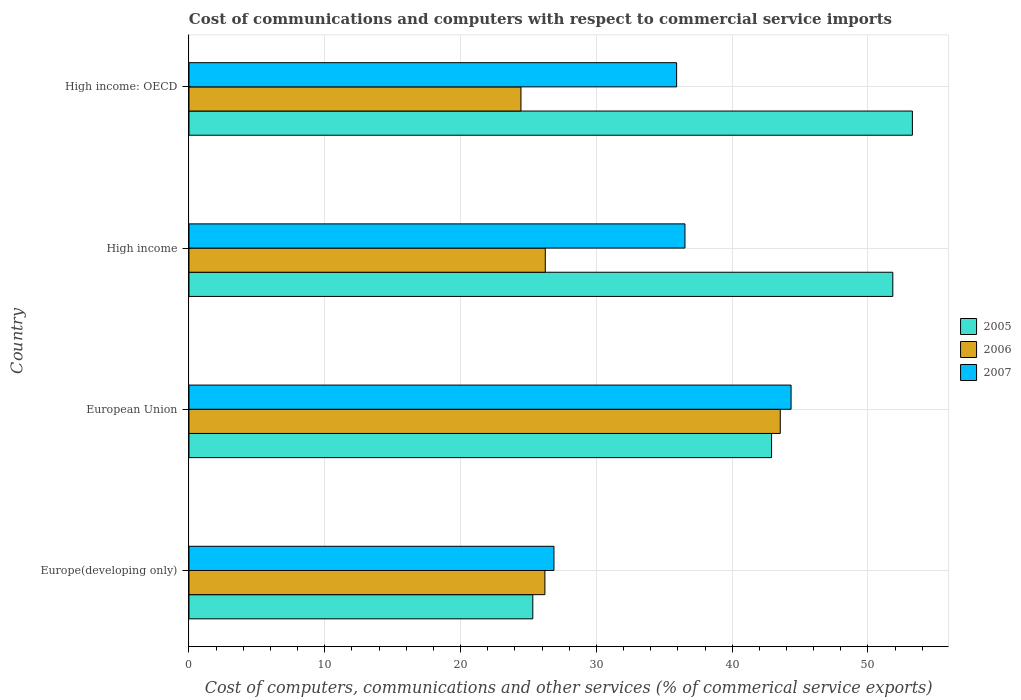How many different coloured bars are there?
Offer a terse response. 3. Are the number of bars per tick equal to the number of legend labels?
Provide a succinct answer. Yes. How many bars are there on the 1st tick from the top?
Give a very brief answer. 3. In how many cases, is the number of bars for a given country not equal to the number of legend labels?
Provide a short and direct response. 0. What is the cost of communications and computers in 2006 in High income?
Keep it short and to the point. 26.24. Across all countries, what is the maximum cost of communications and computers in 2005?
Keep it short and to the point. 53.27. Across all countries, what is the minimum cost of communications and computers in 2005?
Keep it short and to the point. 25.32. In which country was the cost of communications and computers in 2006 maximum?
Keep it short and to the point. European Union. In which country was the cost of communications and computers in 2007 minimum?
Ensure brevity in your answer.  Europe(developing only). What is the total cost of communications and computers in 2006 in the graph?
Provide a short and direct response. 120.44. What is the difference between the cost of communications and computers in 2007 in High income and that in High income: OECD?
Keep it short and to the point. 0.61. What is the difference between the cost of communications and computers in 2005 in High income: OECD and the cost of communications and computers in 2006 in High income?
Your response must be concise. 27.03. What is the average cost of communications and computers in 2006 per country?
Ensure brevity in your answer.  30.11. What is the difference between the cost of communications and computers in 2005 and cost of communications and computers in 2006 in High income?
Your response must be concise. 25.59. What is the ratio of the cost of communications and computers in 2007 in Europe(developing only) to that in High income?
Provide a short and direct response. 0.74. Is the cost of communications and computers in 2005 in Europe(developing only) less than that in High income: OECD?
Your answer should be very brief. Yes. Is the difference between the cost of communications and computers in 2005 in Europe(developing only) and High income: OECD greater than the difference between the cost of communications and computers in 2006 in Europe(developing only) and High income: OECD?
Offer a terse response. No. What is the difference between the highest and the second highest cost of communications and computers in 2007?
Your answer should be compact. 7.81. What is the difference between the highest and the lowest cost of communications and computers in 2006?
Offer a terse response. 19.1. In how many countries, is the cost of communications and computers in 2007 greater than the average cost of communications and computers in 2007 taken over all countries?
Provide a short and direct response. 2. Is it the case that in every country, the sum of the cost of communications and computers in 2005 and cost of communications and computers in 2007 is greater than the cost of communications and computers in 2006?
Your answer should be compact. Yes. How many bars are there?
Provide a succinct answer. 12. Are all the bars in the graph horizontal?
Keep it short and to the point. Yes. How many countries are there in the graph?
Provide a short and direct response. 4. Are the values on the major ticks of X-axis written in scientific E-notation?
Ensure brevity in your answer.  No. Does the graph contain any zero values?
Offer a terse response. No. Does the graph contain grids?
Your response must be concise. Yes. Where does the legend appear in the graph?
Your response must be concise. Center right. What is the title of the graph?
Provide a short and direct response. Cost of communications and computers with respect to commercial service imports. What is the label or title of the X-axis?
Ensure brevity in your answer.  Cost of computers, communications and other services (% of commerical service exports). What is the label or title of the Y-axis?
Offer a terse response. Country. What is the Cost of computers, communications and other services (% of commerical service exports) of 2005 in Europe(developing only)?
Ensure brevity in your answer.  25.32. What is the Cost of computers, communications and other services (% of commerical service exports) of 2006 in Europe(developing only)?
Give a very brief answer. 26.21. What is the Cost of computers, communications and other services (% of commerical service exports) in 2007 in Europe(developing only)?
Your response must be concise. 26.88. What is the Cost of computers, communications and other services (% of commerical service exports) of 2005 in European Union?
Ensure brevity in your answer.  42.9. What is the Cost of computers, communications and other services (% of commerical service exports) in 2006 in European Union?
Provide a short and direct response. 43.54. What is the Cost of computers, communications and other services (% of commerical service exports) of 2007 in European Union?
Give a very brief answer. 44.34. What is the Cost of computers, communications and other services (% of commerical service exports) in 2005 in High income?
Make the answer very short. 51.83. What is the Cost of computers, communications and other services (% of commerical service exports) of 2006 in High income?
Keep it short and to the point. 26.24. What is the Cost of computers, communications and other services (% of commerical service exports) in 2007 in High income?
Offer a very short reply. 36.52. What is the Cost of computers, communications and other services (% of commerical service exports) of 2005 in High income: OECD?
Your answer should be compact. 53.27. What is the Cost of computers, communications and other services (% of commerical service exports) of 2006 in High income: OECD?
Offer a very short reply. 24.45. What is the Cost of computers, communications and other services (% of commerical service exports) in 2007 in High income: OECD?
Offer a very short reply. 35.91. Across all countries, what is the maximum Cost of computers, communications and other services (% of commerical service exports) of 2005?
Keep it short and to the point. 53.27. Across all countries, what is the maximum Cost of computers, communications and other services (% of commerical service exports) in 2006?
Make the answer very short. 43.54. Across all countries, what is the maximum Cost of computers, communications and other services (% of commerical service exports) in 2007?
Ensure brevity in your answer.  44.34. Across all countries, what is the minimum Cost of computers, communications and other services (% of commerical service exports) of 2005?
Your response must be concise. 25.32. Across all countries, what is the minimum Cost of computers, communications and other services (% of commerical service exports) in 2006?
Provide a succinct answer. 24.45. Across all countries, what is the minimum Cost of computers, communications and other services (% of commerical service exports) in 2007?
Your answer should be very brief. 26.88. What is the total Cost of computers, communications and other services (% of commerical service exports) in 2005 in the graph?
Offer a very short reply. 173.32. What is the total Cost of computers, communications and other services (% of commerical service exports) in 2006 in the graph?
Keep it short and to the point. 120.44. What is the total Cost of computers, communications and other services (% of commerical service exports) in 2007 in the graph?
Offer a very short reply. 143.65. What is the difference between the Cost of computers, communications and other services (% of commerical service exports) in 2005 in Europe(developing only) and that in European Union?
Ensure brevity in your answer.  -17.58. What is the difference between the Cost of computers, communications and other services (% of commerical service exports) in 2006 in Europe(developing only) and that in European Union?
Offer a very short reply. -17.33. What is the difference between the Cost of computers, communications and other services (% of commerical service exports) in 2007 in Europe(developing only) and that in European Union?
Your response must be concise. -17.46. What is the difference between the Cost of computers, communications and other services (% of commerical service exports) in 2005 in Europe(developing only) and that in High income?
Offer a very short reply. -26.51. What is the difference between the Cost of computers, communications and other services (% of commerical service exports) in 2006 in Europe(developing only) and that in High income?
Your answer should be very brief. -0.03. What is the difference between the Cost of computers, communications and other services (% of commerical service exports) in 2007 in Europe(developing only) and that in High income?
Offer a terse response. -9.65. What is the difference between the Cost of computers, communications and other services (% of commerical service exports) in 2005 in Europe(developing only) and that in High income: OECD?
Offer a very short reply. -27.95. What is the difference between the Cost of computers, communications and other services (% of commerical service exports) in 2006 in Europe(developing only) and that in High income: OECD?
Give a very brief answer. 1.76. What is the difference between the Cost of computers, communications and other services (% of commerical service exports) of 2007 in Europe(developing only) and that in High income: OECD?
Your answer should be very brief. -9.03. What is the difference between the Cost of computers, communications and other services (% of commerical service exports) of 2005 in European Union and that in High income?
Provide a succinct answer. -8.93. What is the difference between the Cost of computers, communications and other services (% of commerical service exports) in 2006 in European Union and that in High income?
Make the answer very short. 17.3. What is the difference between the Cost of computers, communications and other services (% of commerical service exports) of 2007 in European Union and that in High income?
Keep it short and to the point. 7.81. What is the difference between the Cost of computers, communications and other services (% of commerical service exports) of 2005 in European Union and that in High income: OECD?
Keep it short and to the point. -10.37. What is the difference between the Cost of computers, communications and other services (% of commerical service exports) of 2006 in European Union and that in High income: OECD?
Your answer should be compact. 19.1. What is the difference between the Cost of computers, communications and other services (% of commerical service exports) in 2007 in European Union and that in High income: OECD?
Provide a succinct answer. 8.43. What is the difference between the Cost of computers, communications and other services (% of commerical service exports) in 2005 in High income and that in High income: OECD?
Your response must be concise. -1.44. What is the difference between the Cost of computers, communications and other services (% of commerical service exports) of 2006 in High income and that in High income: OECD?
Your response must be concise. 1.79. What is the difference between the Cost of computers, communications and other services (% of commerical service exports) in 2007 in High income and that in High income: OECD?
Give a very brief answer. 0.61. What is the difference between the Cost of computers, communications and other services (% of commerical service exports) of 2005 in Europe(developing only) and the Cost of computers, communications and other services (% of commerical service exports) of 2006 in European Union?
Offer a terse response. -18.22. What is the difference between the Cost of computers, communications and other services (% of commerical service exports) in 2005 in Europe(developing only) and the Cost of computers, communications and other services (% of commerical service exports) in 2007 in European Union?
Ensure brevity in your answer.  -19.02. What is the difference between the Cost of computers, communications and other services (% of commerical service exports) of 2006 in Europe(developing only) and the Cost of computers, communications and other services (% of commerical service exports) of 2007 in European Union?
Make the answer very short. -18.13. What is the difference between the Cost of computers, communications and other services (% of commerical service exports) of 2005 in Europe(developing only) and the Cost of computers, communications and other services (% of commerical service exports) of 2006 in High income?
Your answer should be compact. -0.92. What is the difference between the Cost of computers, communications and other services (% of commerical service exports) in 2005 in Europe(developing only) and the Cost of computers, communications and other services (% of commerical service exports) in 2007 in High income?
Offer a very short reply. -11.21. What is the difference between the Cost of computers, communications and other services (% of commerical service exports) of 2006 in Europe(developing only) and the Cost of computers, communications and other services (% of commerical service exports) of 2007 in High income?
Give a very brief answer. -10.31. What is the difference between the Cost of computers, communications and other services (% of commerical service exports) in 2005 in Europe(developing only) and the Cost of computers, communications and other services (% of commerical service exports) in 2006 in High income: OECD?
Offer a terse response. 0.87. What is the difference between the Cost of computers, communications and other services (% of commerical service exports) in 2005 in Europe(developing only) and the Cost of computers, communications and other services (% of commerical service exports) in 2007 in High income: OECD?
Your response must be concise. -10.59. What is the difference between the Cost of computers, communications and other services (% of commerical service exports) of 2006 in Europe(developing only) and the Cost of computers, communications and other services (% of commerical service exports) of 2007 in High income: OECD?
Your answer should be very brief. -9.7. What is the difference between the Cost of computers, communications and other services (% of commerical service exports) of 2005 in European Union and the Cost of computers, communications and other services (% of commerical service exports) of 2006 in High income?
Offer a very short reply. 16.66. What is the difference between the Cost of computers, communications and other services (% of commerical service exports) in 2005 in European Union and the Cost of computers, communications and other services (% of commerical service exports) in 2007 in High income?
Offer a very short reply. 6.38. What is the difference between the Cost of computers, communications and other services (% of commerical service exports) in 2006 in European Union and the Cost of computers, communications and other services (% of commerical service exports) in 2007 in High income?
Give a very brief answer. 7.02. What is the difference between the Cost of computers, communications and other services (% of commerical service exports) of 2005 in European Union and the Cost of computers, communications and other services (% of commerical service exports) of 2006 in High income: OECD?
Your answer should be very brief. 18.46. What is the difference between the Cost of computers, communications and other services (% of commerical service exports) in 2005 in European Union and the Cost of computers, communications and other services (% of commerical service exports) in 2007 in High income: OECD?
Your response must be concise. 6.99. What is the difference between the Cost of computers, communications and other services (% of commerical service exports) of 2006 in European Union and the Cost of computers, communications and other services (% of commerical service exports) of 2007 in High income: OECD?
Your response must be concise. 7.63. What is the difference between the Cost of computers, communications and other services (% of commerical service exports) in 2005 in High income and the Cost of computers, communications and other services (% of commerical service exports) in 2006 in High income: OECD?
Provide a succinct answer. 27.38. What is the difference between the Cost of computers, communications and other services (% of commerical service exports) of 2005 in High income and the Cost of computers, communications and other services (% of commerical service exports) of 2007 in High income: OECD?
Make the answer very short. 15.92. What is the difference between the Cost of computers, communications and other services (% of commerical service exports) in 2006 in High income and the Cost of computers, communications and other services (% of commerical service exports) in 2007 in High income: OECD?
Ensure brevity in your answer.  -9.67. What is the average Cost of computers, communications and other services (% of commerical service exports) of 2005 per country?
Ensure brevity in your answer.  43.33. What is the average Cost of computers, communications and other services (% of commerical service exports) of 2006 per country?
Ensure brevity in your answer.  30.11. What is the average Cost of computers, communications and other services (% of commerical service exports) of 2007 per country?
Offer a terse response. 35.91. What is the difference between the Cost of computers, communications and other services (% of commerical service exports) in 2005 and Cost of computers, communications and other services (% of commerical service exports) in 2006 in Europe(developing only)?
Your answer should be very brief. -0.89. What is the difference between the Cost of computers, communications and other services (% of commerical service exports) of 2005 and Cost of computers, communications and other services (% of commerical service exports) of 2007 in Europe(developing only)?
Ensure brevity in your answer.  -1.56. What is the difference between the Cost of computers, communications and other services (% of commerical service exports) in 2006 and Cost of computers, communications and other services (% of commerical service exports) in 2007 in Europe(developing only)?
Ensure brevity in your answer.  -0.67. What is the difference between the Cost of computers, communications and other services (% of commerical service exports) of 2005 and Cost of computers, communications and other services (% of commerical service exports) of 2006 in European Union?
Ensure brevity in your answer.  -0.64. What is the difference between the Cost of computers, communications and other services (% of commerical service exports) of 2005 and Cost of computers, communications and other services (% of commerical service exports) of 2007 in European Union?
Ensure brevity in your answer.  -1.44. What is the difference between the Cost of computers, communications and other services (% of commerical service exports) of 2006 and Cost of computers, communications and other services (% of commerical service exports) of 2007 in European Union?
Your answer should be very brief. -0.8. What is the difference between the Cost of computers, communications and other services (% of commerical service exports) of 2005 and Cost of computers, communications and other services (% of commerical service exports) of 2006 in High income?
Your answer should be very brief. 25.59. What is the difference between the Cost of computers, communications and other services (% of commerical service exports) in 2005 and Cost of computers, communications and other services (% of commerical service exports) in 2007 in High income?
Your response must be concise. 15.31. What is the difference between the Cost of computers, communications and other services (% of commerical service exports) in 2006 and Cost of computers, communications and other services (% of commerical service exports) in 2007 in High income?
Ensure brevity in your answer.  -10.29. What is the difference between the Cost of computers, communications and other services (% of commerical service exports) of 2005 and Cost of computers, communications and other services (% of commerical service exports) of 2006 in High income: OECD?
Provide a short and direct response. 28.83. What is the difference between the Cost of computers, communications and other services (% of commerical service exports) in 2005 and Cost of computers, communications and other services (% of commerical service exports) in 2007 in High income: OECD?
Offer a very short reply. 17.36. What is the difference between the Cost of computers, communications and other services (% of commerical service exports) in 2006 and Cost of computers, communications and other services (% of commerical service exports) in 2007 in High income: OECD?
Provide a succinct answer. -11.46. What is the ratio of the Cost of computers, communications and other services (% of commerical service exports) of 2005 in Europe(developing only) to that in European Union?
Keep it short and to the point. 0.59. What is the ratio of the Cost of computers, communications and other services (% of commerical service exports) in 2006 in Europe(developing only) to that in European Union?
Provide a short and direct response. 0.6. What is the ratio of the Cost of computers, communications and other services (% of commerical service exports) in 2007 in Europe(developing only) to that in European Union?
Your answer should be very brief. 0.61. What is the ratio of the Cost of computers, communications and other services (% of commerical service exports) of 2005 in Europe(developing only) to that in High income?
Ensure brevity in your answer.  0.49. What is the ratio of the Cost of computers, communications and other services (% of commerical service exports) in 2006 in Europe(developing only) to that in High income?
Your answer should be compact. 1. What is the ratio of the Cost of computers, communications and other services (% of commerical service exports) in 2007 in Europe(developing only) to that in High income?
Keep it short and to the point. 0.74. What is the ratio of the Cost of computers, communications and other services (% of commerical service exports) in 2005 in Europe(developing only) to that in High income: OECD?
Give a very brief answer. 0.48. What is the ratio of the Cost of computers, communications and other services (% of commerical service exports) of 2006 in Europe(developing only) to that in High income: OECD?
Keep it short and to the point. 1.07. What is the ratio of the Cost of computers, communications and other services (% of commerical service exports) of 2007 in Europe(developing only) to that in High income: OECD?
Keep it short and to the point. 0.75. What is the ratio of the Cost of computers, communications and other services (% of commerical service exports) in 2005 in European Union to that in High income?
Offer a terse response. 0.83. What is the ratio of the Cost of computers, communications and other services (% of commerical service exports) of 2006 in European Union to that in High income?
Make the answer very short. 1.66. What is the ratio of the Cost of computers, communications and other services (% of commerical service exports) in 2007 in European Union to that in High income?
Your response must be concise. 1.21. What is the ratio of the Cost of computers, communications and other services (% of commerical service exports) in 2005 in European Union to that in High income: OECD?
Your answer should be compact. 0.81. What is the ratio of the Cost of computers, communications and other services (% of commerical service exports) in 2006 in European Union to that in High income: OECD?
Make the answer very short. 1.78. What is the ratio of the Cost of computers, communications and other services (% of commerical service exports) of 2007 in European Union to that in High income: OECD?
Make the answer very short. 1.23. What is the ratio of the Cost of computers, communications and other services (% of commerical service exports) of 2005 in High income to that in High income: OECD?
Make the answer very short. 0.97. What is the ratio of the Cost of computers, communications and other services (% of commerical service exports) in 2006 in High income to that in High income: OECD?
Ensure brevity in your answer.  1.07. What is the ratio of the Cost of computers, communications and other services (% of commerical service exports) of 2007 in High income to that in High income: OECD?
Your answer should be very brief. 1.02. What is the difference between the highest and the second highest Cost of computers, communications and other services (% of commerical service exports) of 2005?
Make the answer very short. 1.44. What is the difference between the highest and the second highest Cost of computers, communications and other services (% of commerical service exports) of 2006?
Your answer should be very brief. 17.3. What is the difference between the highest and the second highest Cost of computers, communications and other services (% of commerical service exports) in 2007?
Make the answer very short. 7.81. What is the difference between the highest and the lowest Cost of computers, communications and other services (% of commerical service exports) in 2005?
Ensure brevity in your answer.  27.95. What is the difference between the highest and the lowest Cost of computers, communications and other services (% of commerical service exports) in 2006?
Make the answer very short. 19.1. What is the difference between the highest and the lowest Cost of computers, communications and other services (% of commerical service exports) of 2007?
Your answer should be compact. 17.46. 